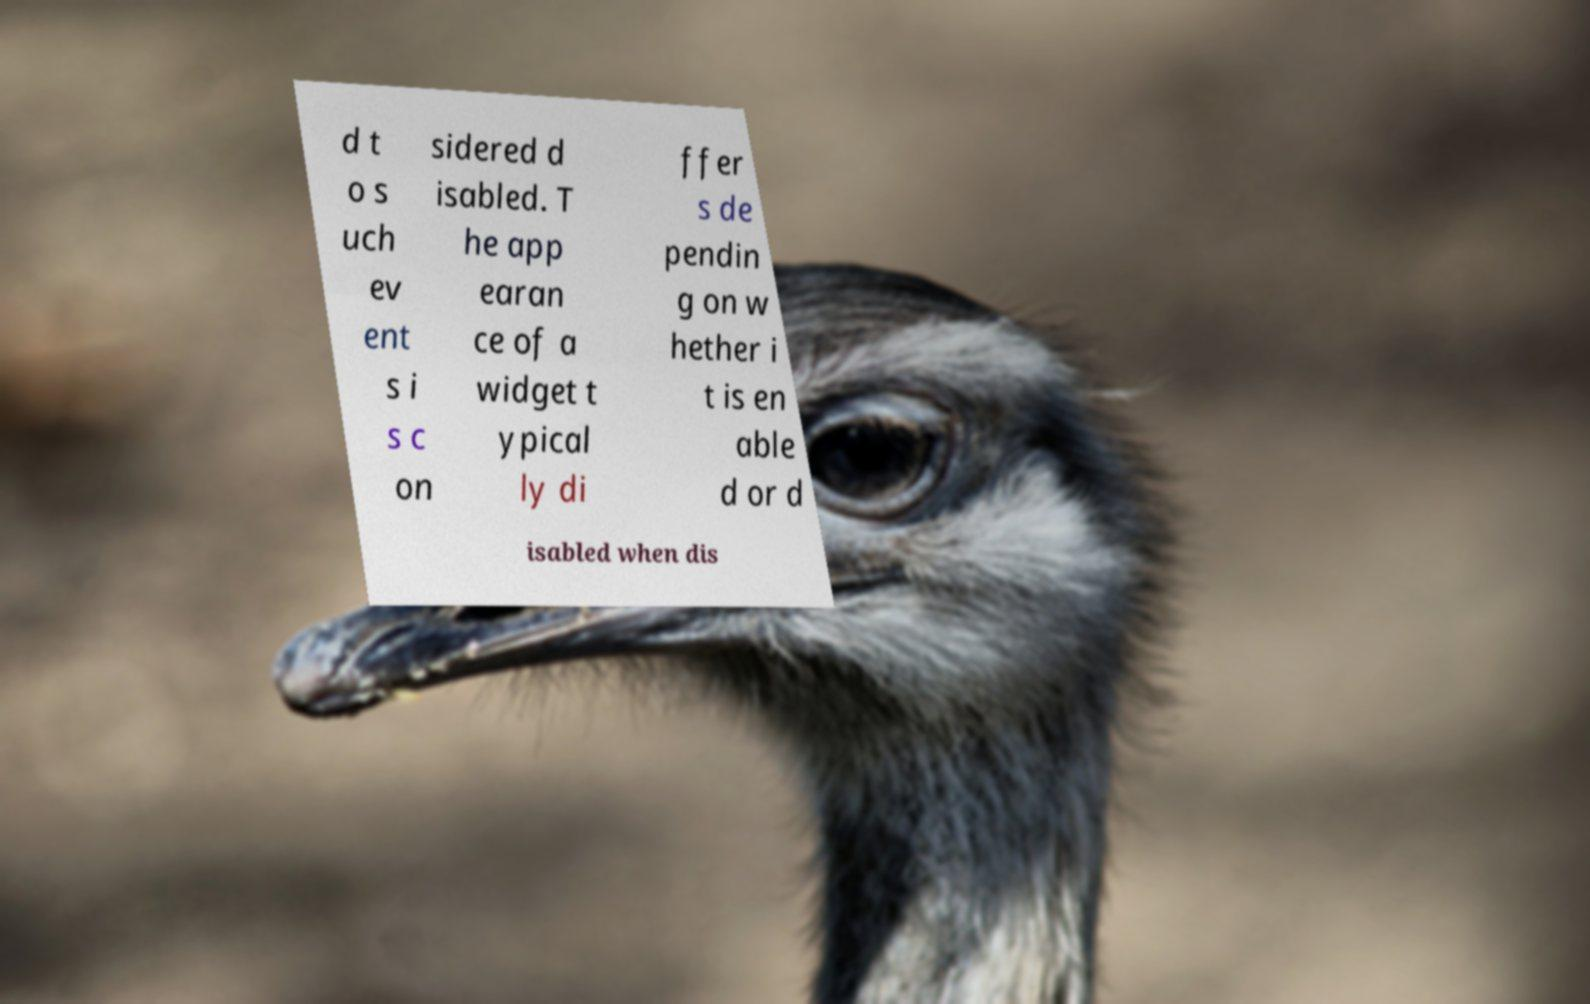I need the written content from this picture converted into text. Can you do that? d t o s uch ev ent s i s c on sidered d isabled. T he app earan ce of a widget t ypical ly di ffer s de pendin g on w hether i t is en able d or d isabled when dis 